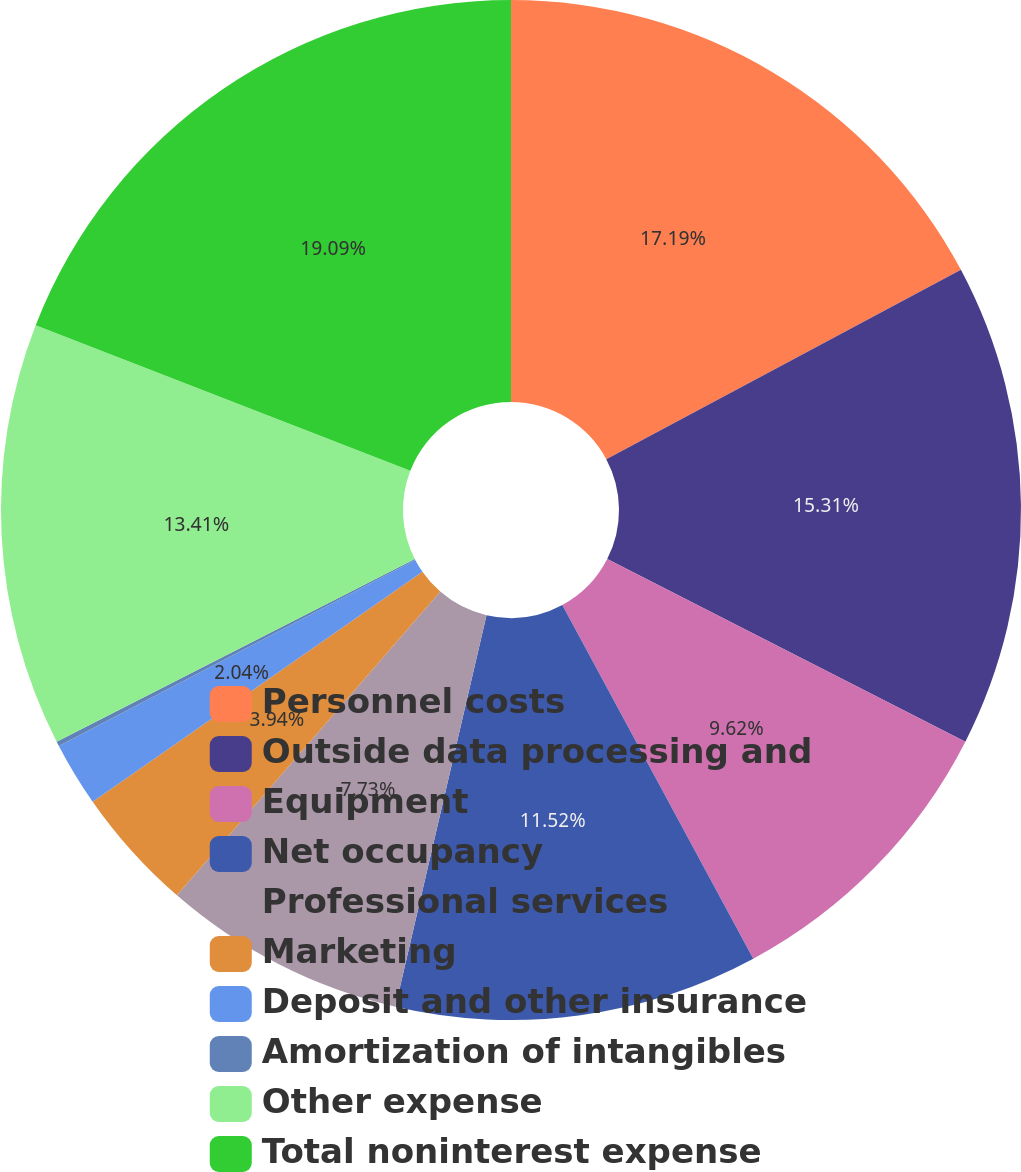Convert chart to OTSL. <chart><loc_0><loc_0><loc_500><loc_500><pie_chart><fcel>Personnel costs<fcel>Outside data processing and<fcel>Equipment<fcel>Net occupancy<fcel>Professional services<fcel>Marketing<fcel>Deposit and other insurance<fcel>Amortization of intangibles<fcel>Other expense<fcel>Total noninterest expense<nl><fcel>17.2%<fcel>15.31%<fcel>9.62%<fcel>11.52%<fcel>7.73%<fcel>3.94%<fcel>2.04%<fcel>0.15%<fcel>13.41%<fcel>19.1%<nl></chart> 